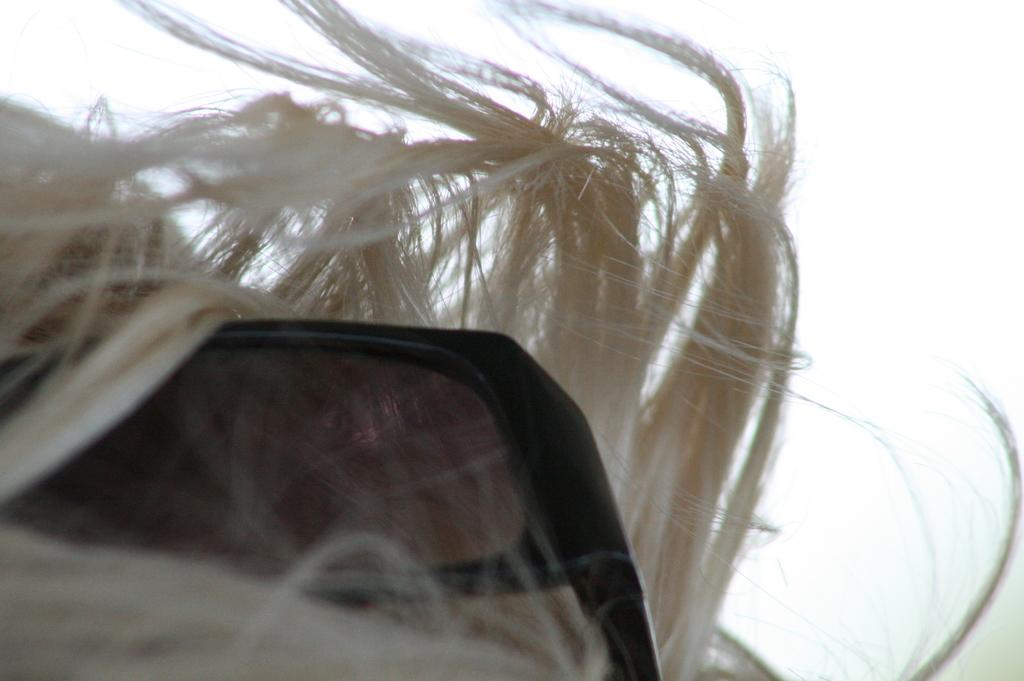What type of human hair is visible in the image? There is human hair in the image, but the specific type cannot be determined from the provided facts. What accessory can be seen in the image? There are sunglasses in the image. What is the condition of the sky in the image? The sky is cloudy in the image. What type of line or curve can be seen in the image? There is no specific line or curve mentioned in the provided facts, so it cannot be determined from the image. Can you tell me how many chickens are present in the image? There is no mention of chickens in the provided facts, so it cannot be determined from the image. 